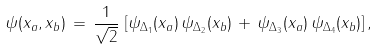<formula> <loc_0><loc_0><loc_500><loc_500>\psi ( { x } _ { a } , { x } _ { b } ) \, = \, \frac { 1 } { \sqrt { 2 } } \, \left [ \psi _ { \Delta _ { 1 } } ( { x } _ { a } ) \, \psi _ { \Delta _ { 2 } } ( { x } _ { b } ) \, + \, \psi _ { \Delta _ { 3 } } ( { x } _ { a } ) \, \psi _ { \Delta _ { 4 } } ( { x } _ { b } ) \right ] ,</formula> 